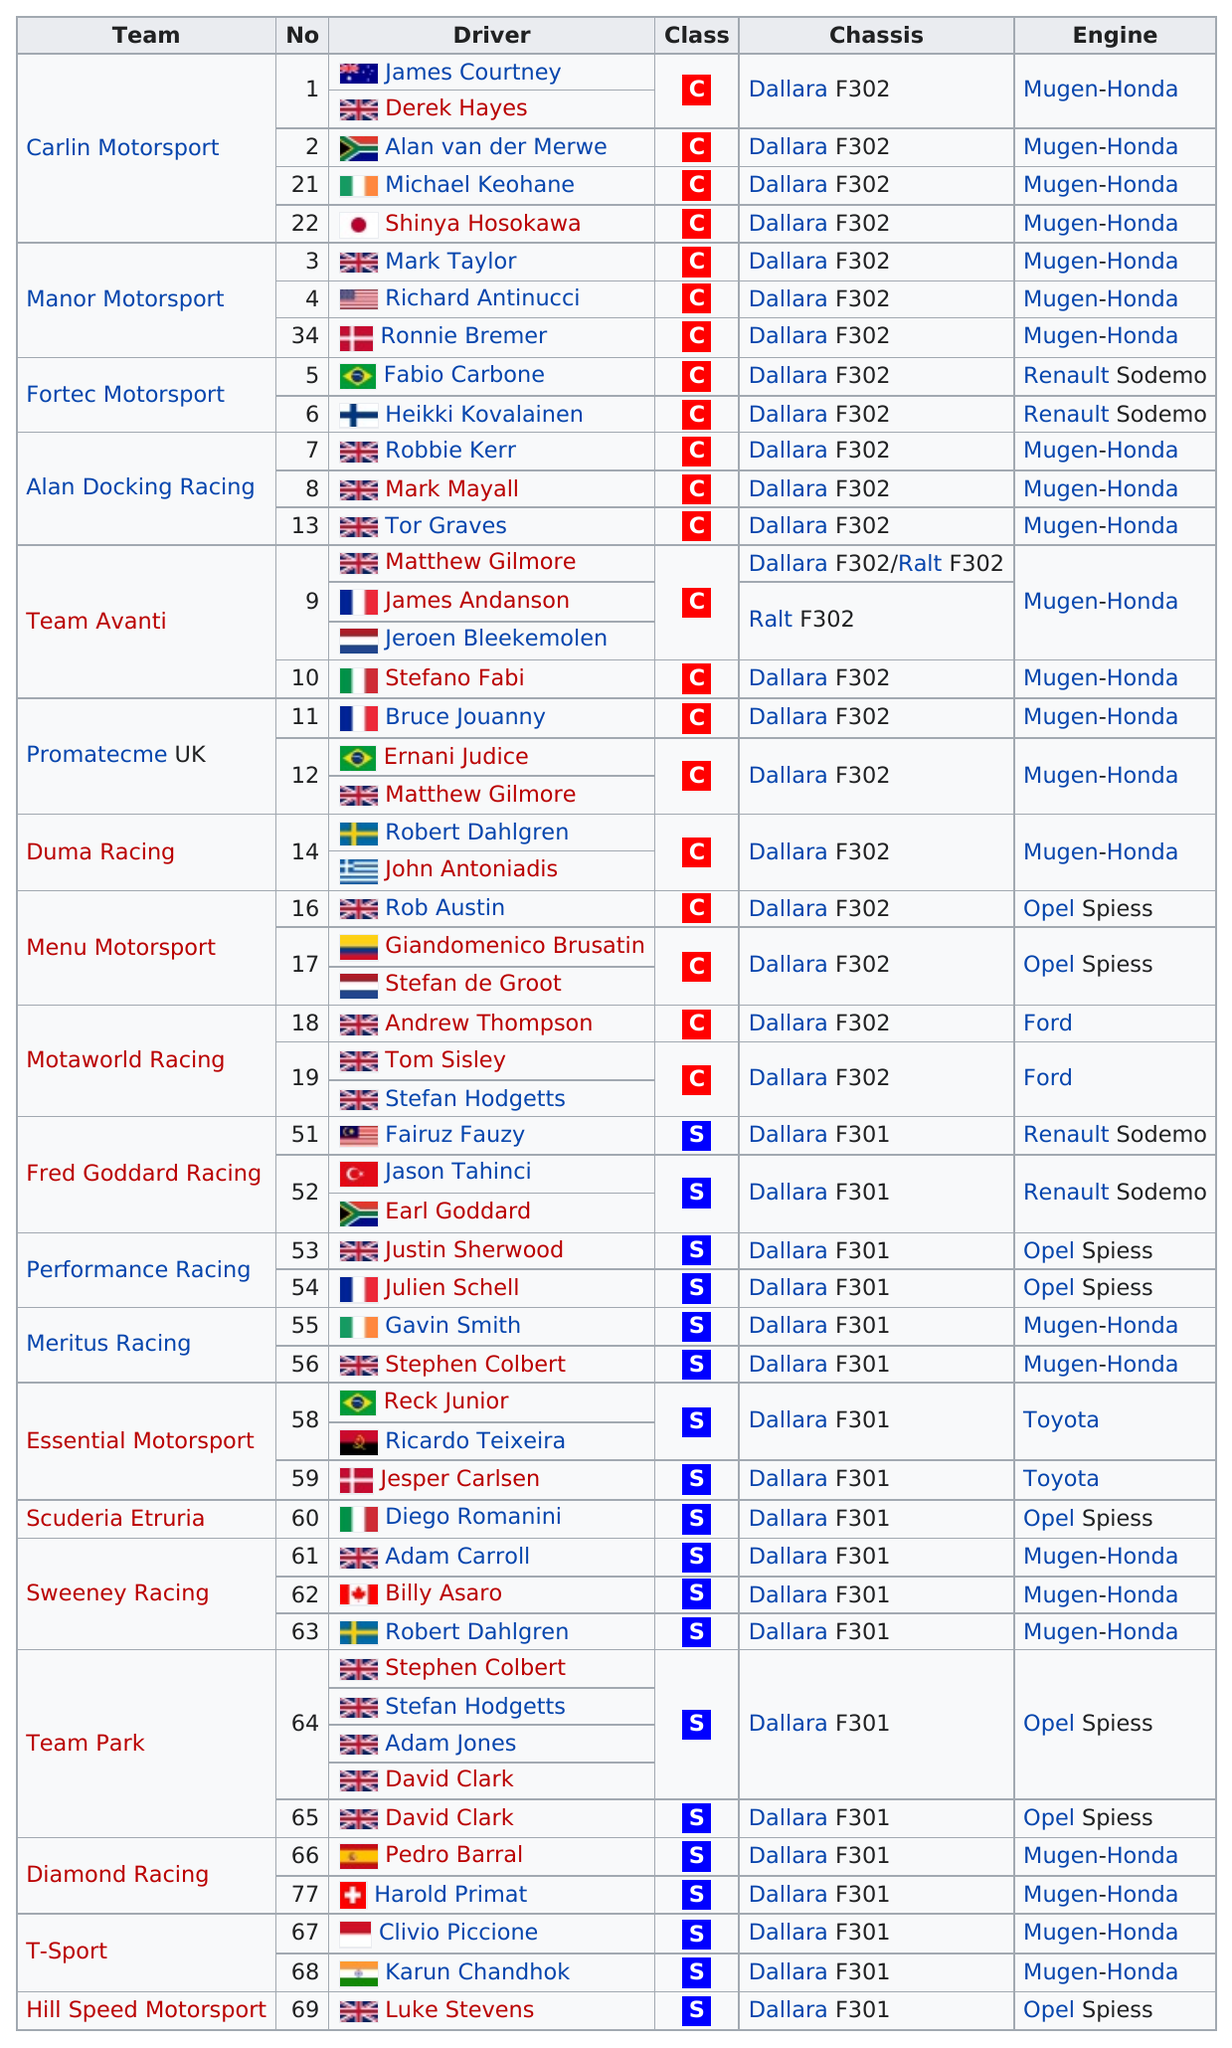Outline some significant characteristics in this image. The Mugen-Honda engine was the most utilized by teams during this season. There are 19 scholarship teams listed on the chart. Harold Prime's driver has the highest number. During the current F1 season, a total of 19 drivers did not compete in C-class cars. The total number of Class C (Championship) teams is 21. 